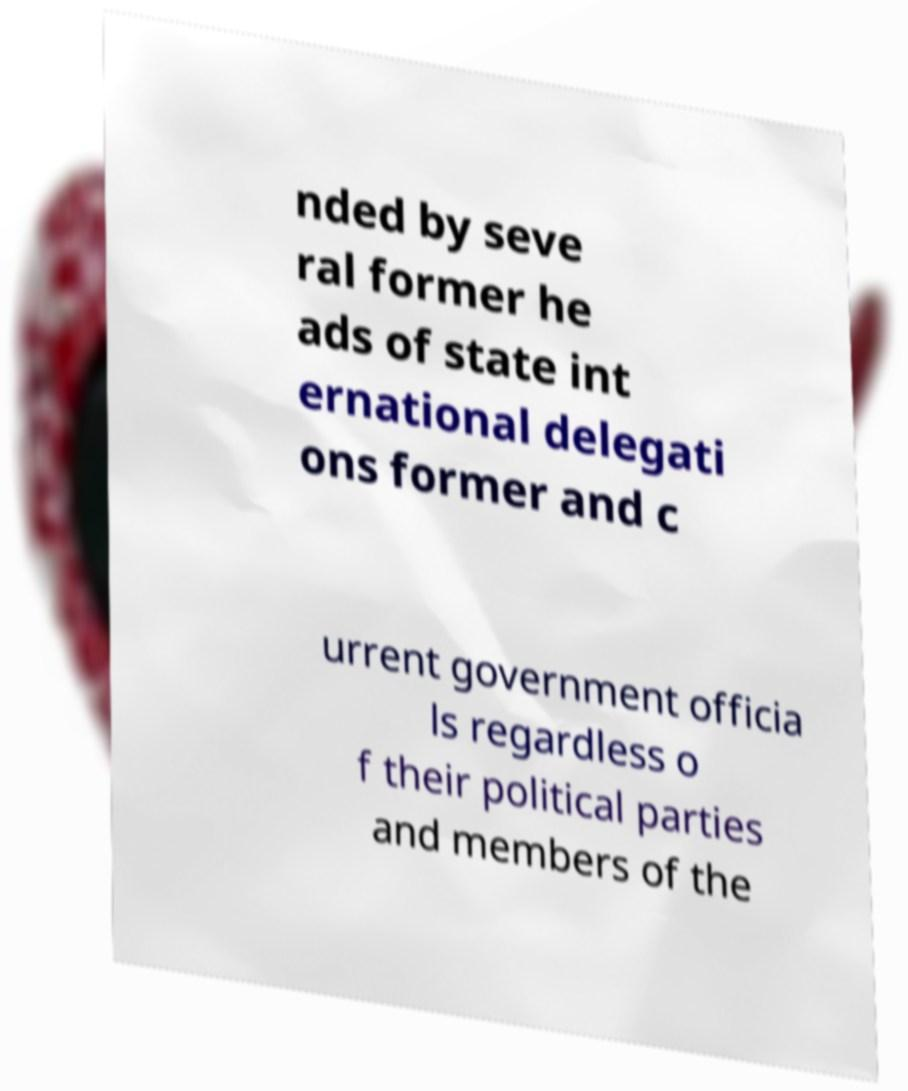There's text embedded in this image that I need extracted. Can you transcribe it verbatim? nded by seve ral former he ads of state int ernational delegati ons former and c urrent government officia ls regardless o f their political parties and members of the 